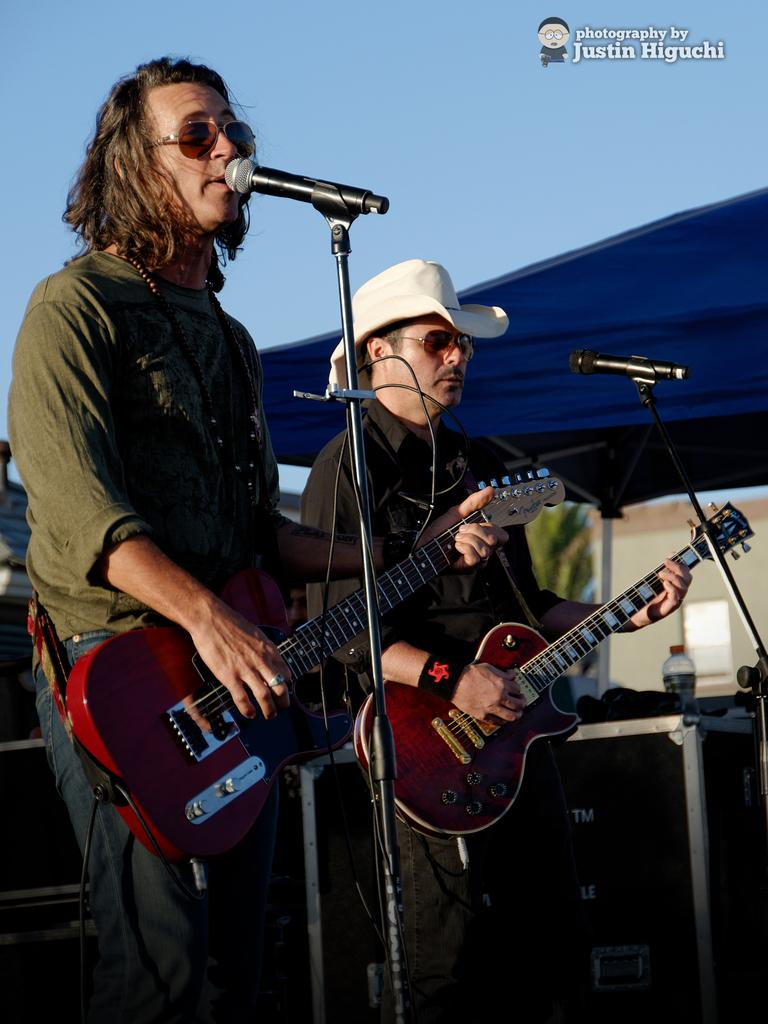How many people are in the image? There are two men in the image. What are the men holding in the image? Both men are holding guitars. What are the men standing in front of? The men are standing in front of microphones. What can be seen in the background of the image? There is a bottle and the sky visible in the background. What type of machine is being used by the men in the image? There is no machine visible in the image; the men are holding guitars and standing in front of microphones. 